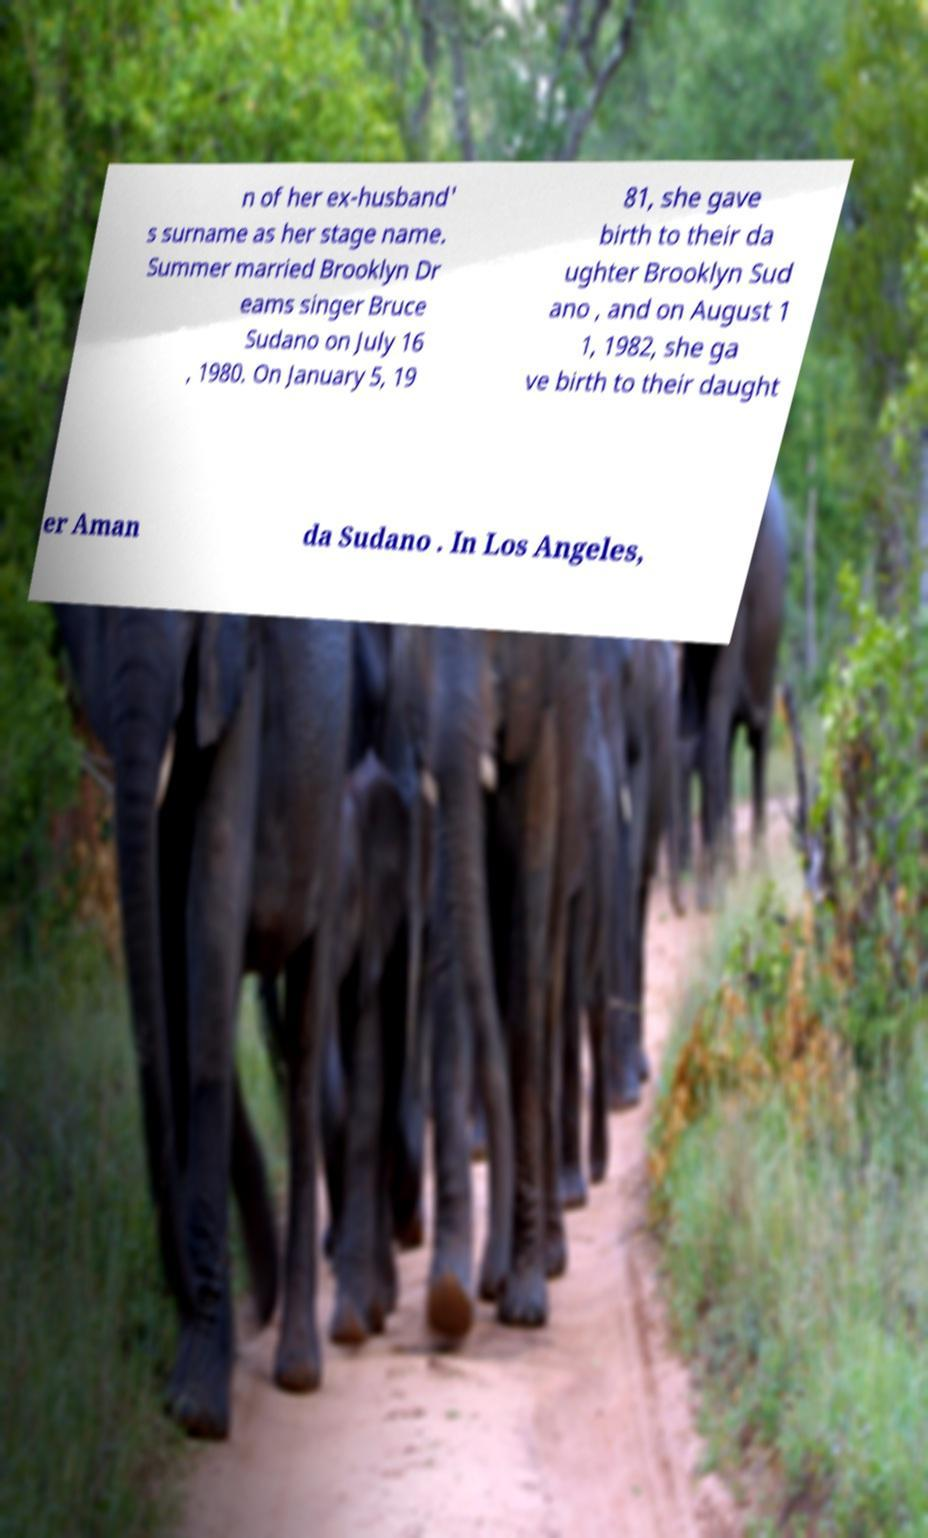Can you read and provide the text displayed in the image?This photo seems to have some interesting text. Can you extract and type it out for me? n of her ex-husband' s surname as her stage name. Summer married Brooklyn Dr eams singer Bruce Sudano on July 16 , 1980. On January 5, 19 81, she gave birth to their da ughter Brooklyn Sud ano , and on August 1 1, 1982, she ga ve birth to their daught er Aman da Sudano . In Los Angeles, 